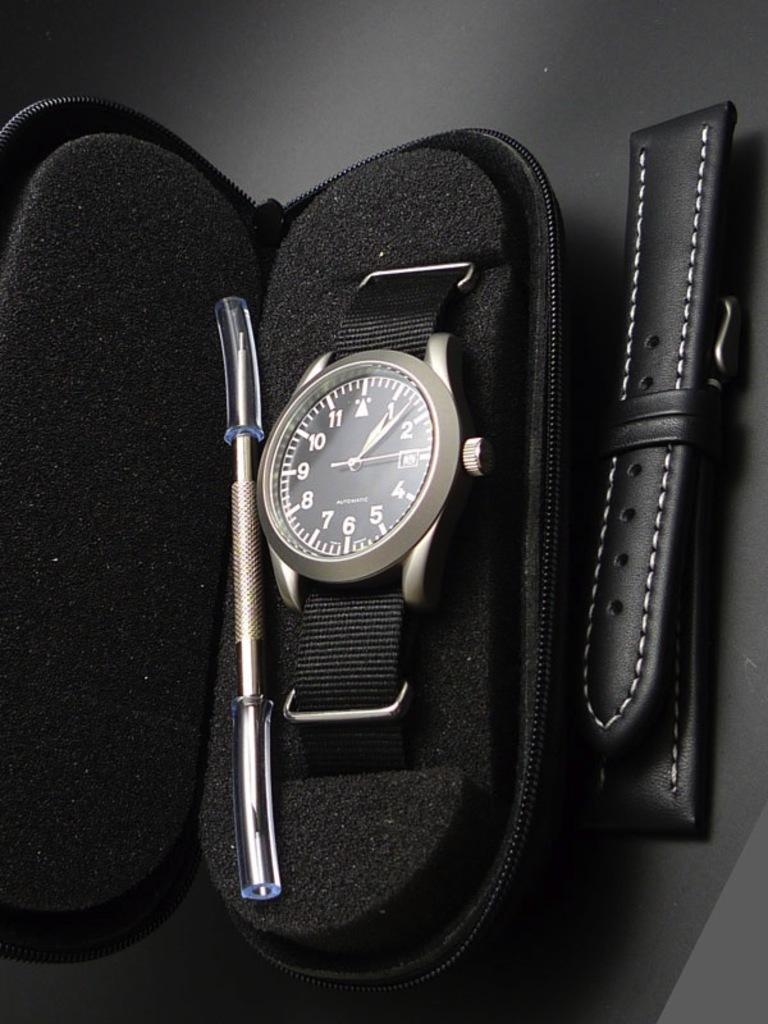<image>
Provide a brief description of the given image. A black watch in a case that has the hour hand on the "1" and the second hand on the "3" 